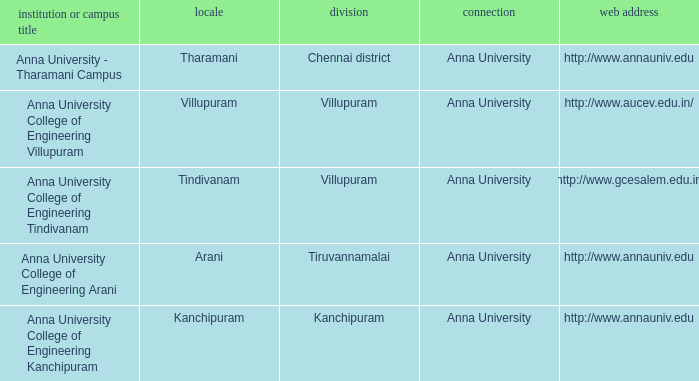What District has a College or Campus Name of anna university college of engineering kanchipuram? Kanchipuram. 